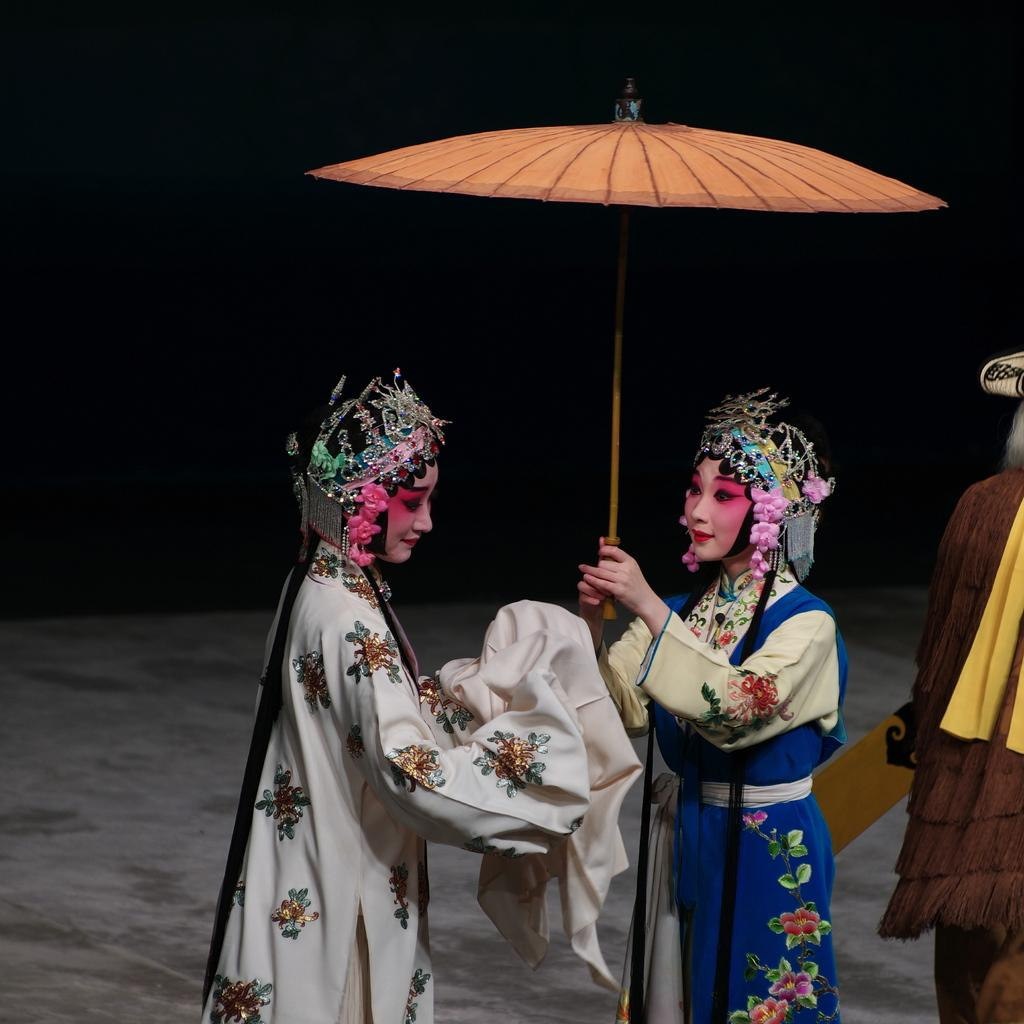How many women are in the image? There are two women standing in the image. What are the women wearing? The women are wearing fancy dresses. What is one of the women holding? One of the women is holding an umbrella. Can you describe the person on the right side of the image? There is a person standing on the right side of the image, but no specific details about their appearance or clothing are provided. What is the lighting condition in the image? The background of the image appears dark. What type of news can be heard coming from the island in the image? There is no island present in the image, so it's not possible to determine what, if any, news might be heard. 